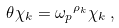<formula> <loc_0><loc_0><loc_500><loc_500>\theta \chi _ { k } = { \omega _ { p } } ^ { \rho _ { k } } \chi _ { k } \, ,</formula> 